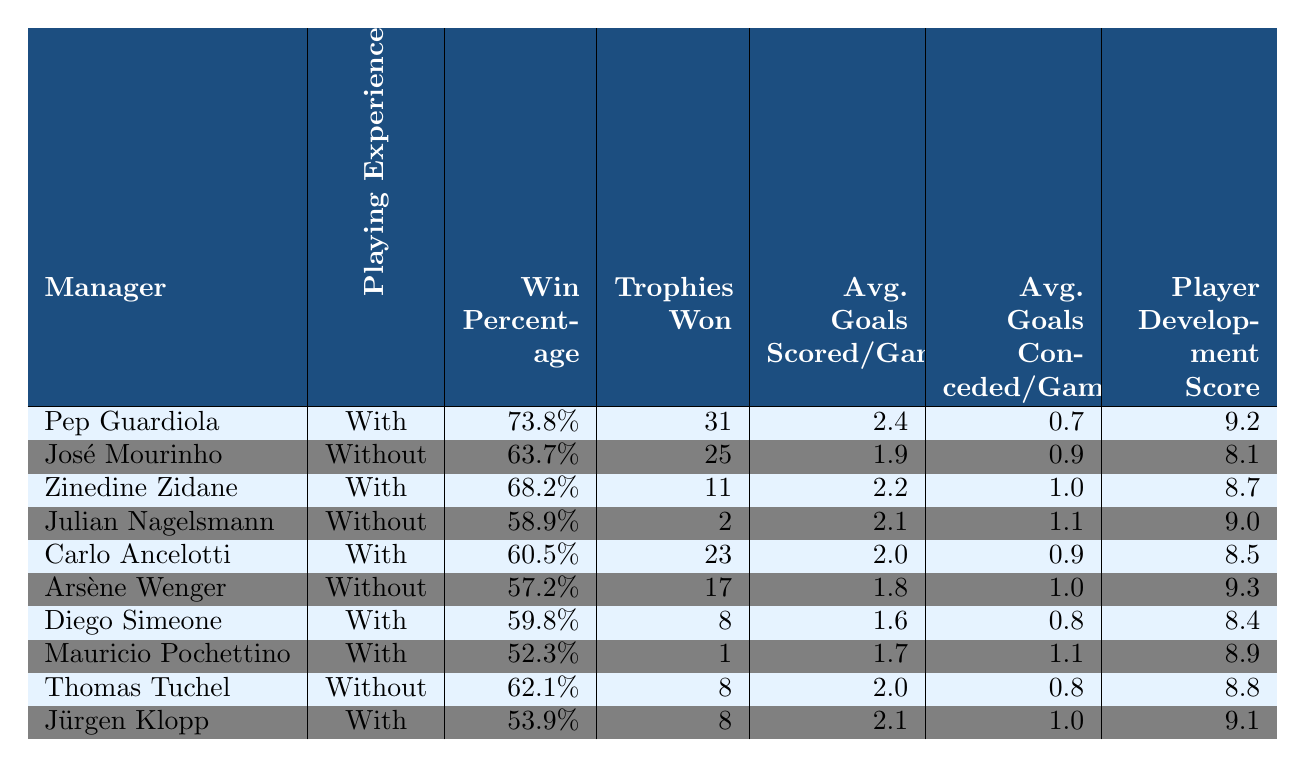What is the win percentage of Pep Guardiola? The table shows that Pep Guardiola has a win percentage of 73.8%.
Answer: 73.8% Which manager has the highest player development score? Observing the table, Pep Guardiola has the highest player development score at 9.2.
Answer: Pep Guardiola How many trophies did Jürgen Klopp win? According to the table, Jürgen Klopp won 8 trophies.
Answer: 8 What is the average goals conceded per game for managers with playing experience? The managers with playing experience are Pep Guardiola, Zinedine Zidane, Carlo Ancelotti, Diego Simeone, and Mauricio Pochettino. Their average goals conceded are 0.7, 1.0, 0.9, 0.8, and 1.1 respectively. The sum is 0.7 + 1.0 + 0.9 + 0.8 + 1.1 = 4.5. Dividing by the number of managers (5) gives an average of 4.5 / 5 = 0.9.
Answer: 0.9 Did any manager without prior playing experience win more trophies than Diego Simeone? Diego Simeone won 8 trophies, while José Mourinho won 25, Julian Nagelsmann won 2, and Thomas Tuchel won 8. So, Mourinho is the only one with more trophies than Simeone.
Answer: Yes What is the difference in win percentage between managers with and without playing experience? The average win percentage of managers with playing experience is (73.8 + 68.2 + 60.5 + 59.8 + 52.3) / 5 = 62.14%. The average win percentage of those without is (63.7 + 58.9 + 57.2 + 62.1) / 4 = 60.25%. The difference is 62.14 - 60.25 = 1.89%.
Answer: 1.89% Which manager has the lowest average goals scored per game? Looking at the table, Diego Simeone has the lowest average goals scored per game at 1.6.
Answer: Diego Simeone How does the player development score of managers with playing experience compare to those without? The average player development score for managers with playing experience is (9.2 + 8.7 + 8.5 + 8.4 + 8.9) / 5 = 8.74. For those without, it is (8.1 + 9.0 + 9.3 + 8.8) / 4 = 8.575. Therefore, managers with experience have a higher average score.
Answer: Higher What is the trophy-winning average of managers without playing experience? The managers without playing experience are José Mourinho (25), Julian Nagelsmann (2), Arsène Wenger (17), and Thomas Tuchel (8). Summing these yields 25 + 2 + 17 + 8 = 52. Dividing by 4 gives an average of 52 / 4 = 13.
Answer: 13 